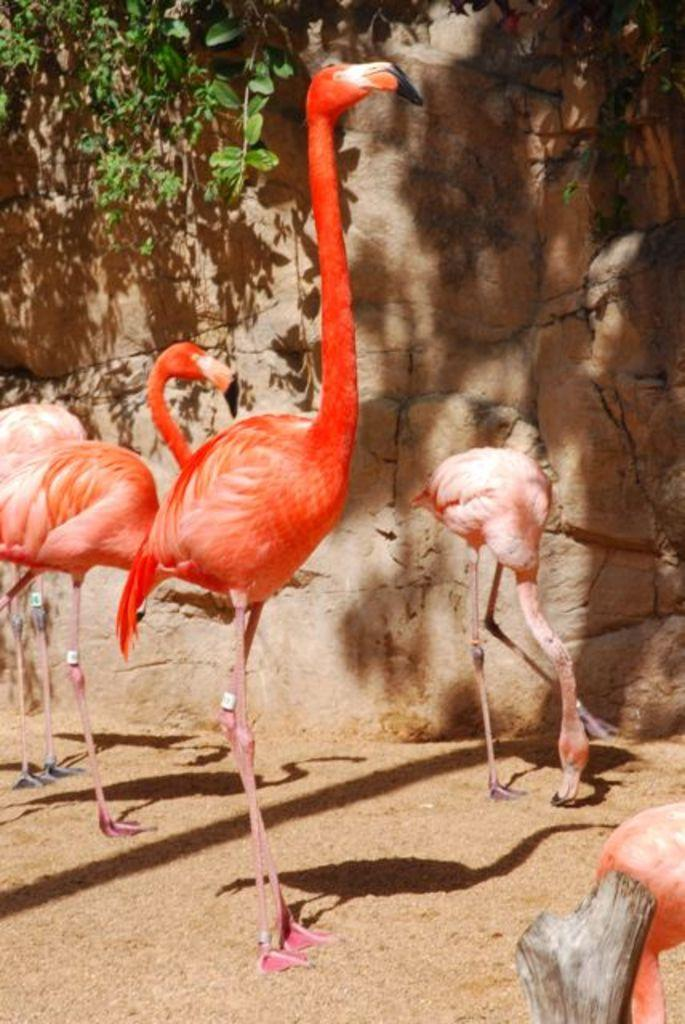What animals are in the center of the image? There are flamingos in the center of the image. What is the surface on which the flamingos are standing? The flamingos are standing on sand. What can be seen in the background of the image? There is a wall and a tree in the background of the image. How many haircuts are being given to the flamingos in the image? There are no haircuts being given to the flamingos in the image, as they are wild animals and not receiving any grooming services. 